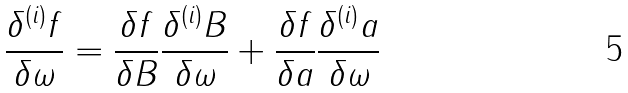Convert formula to latex. <formula><loc_0><loc_0><loc_500><loc_500>\frac { \delta ^ { ( i ) } f } { \delta \omega } = \frac { \delta f } { \delta B } \frac { \delta ^ { ( i ) } B } { \delta \omega } + \frac { \delta f } { \delta a } \frac { \delta ^ { ( i ) } a } { \delta \omega }</formula> 